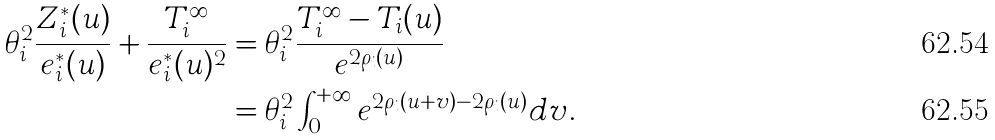<formula> <loc_0><loc_0><loc_500><loc_500>\theta _ { i } ^ { 2 } \frac { Z _ { i } ^ { * } ( u ) } { e _ { i } ^ { * } ( u ) } + \frac { T _ { i } ^ { \infty } } { e _ { i } ^ { * } ( u ) ^ { 2 } } & = \theta _ { i } ^ { 2 } \frac { T _ { i } ^ { \infty } - T _ { i } ( u ) } { e ^ { 2 \rho _ { i } ( u ) } } \\ & = \theta _ { i } ^ { 2 } \int _ { 0 } ^ { + \infty } e ^ { 2 \rho _ { i } ( u + v ) - 2 \rho _ { i } ( u ) } d v .</formula> 